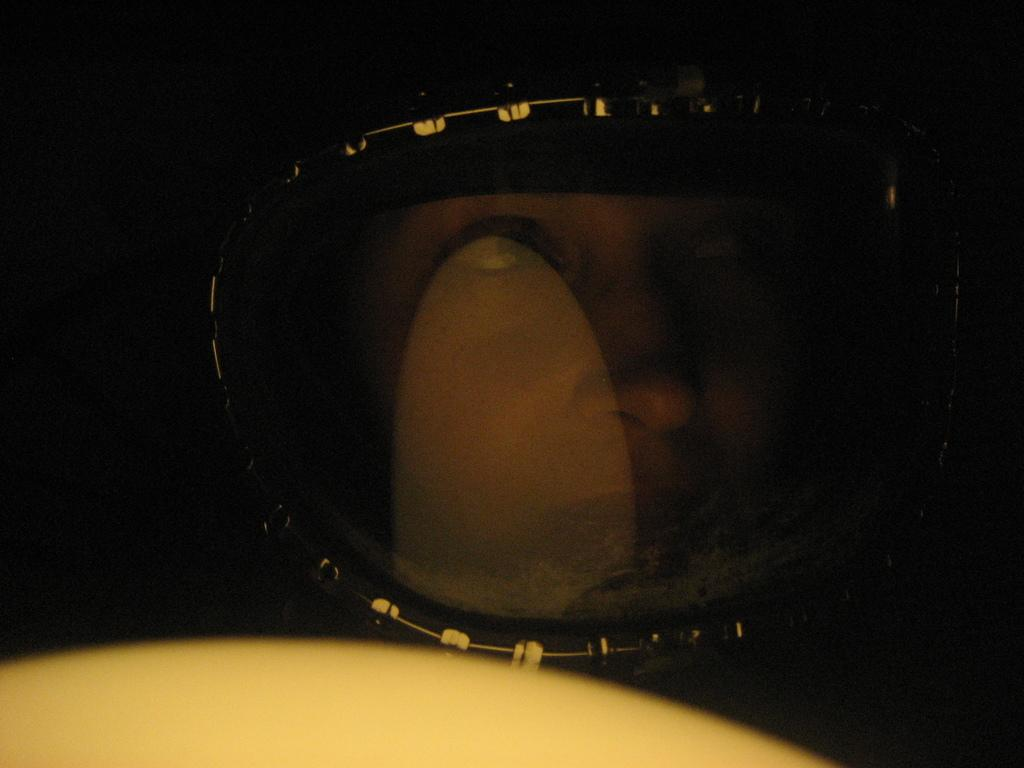What is the main subject of the image? There is a person in the image. What is the person wearing in the image? The person is wearing a helmet. How many apples can be seen in the image? There are no apples present in the image. What type of grape is the person holding in the image? There is no grape present in the image. 